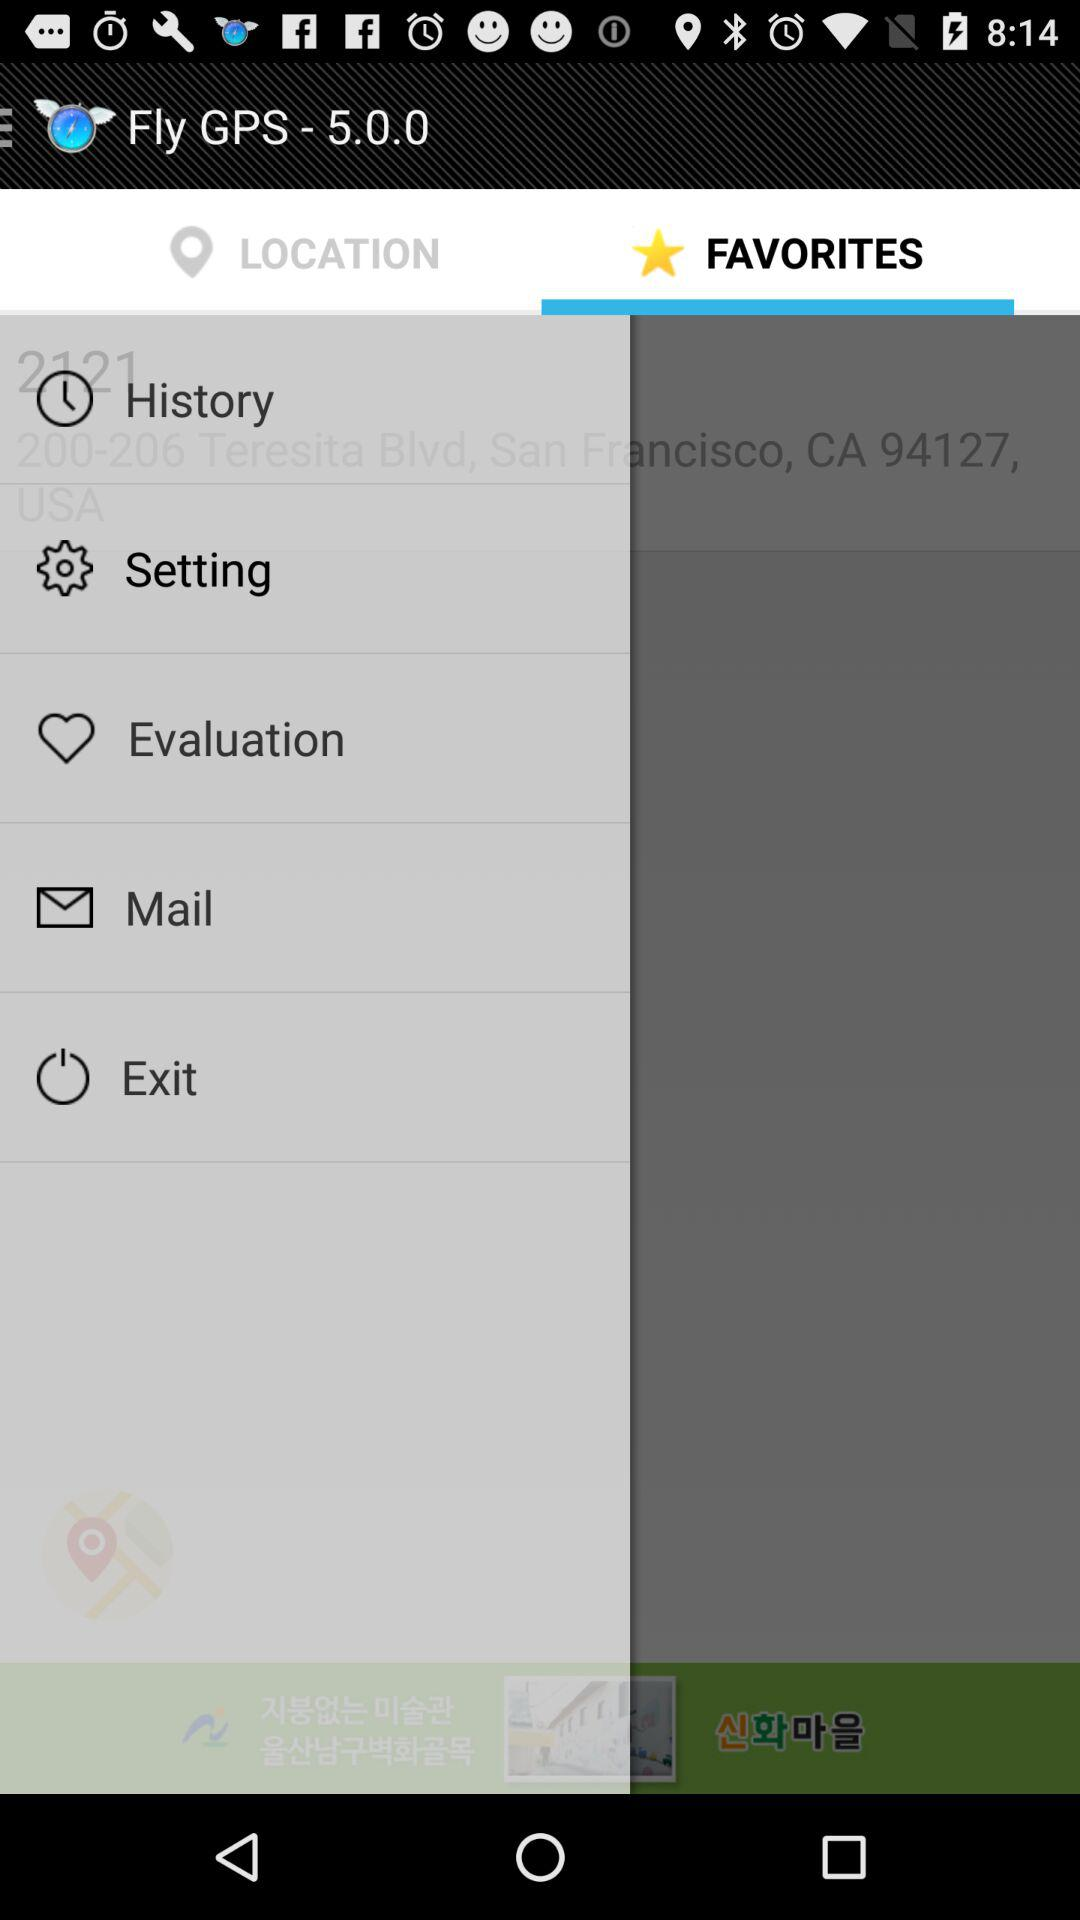What is the name of the application? The name of the application is "Fly GPS - 5.0.0". 